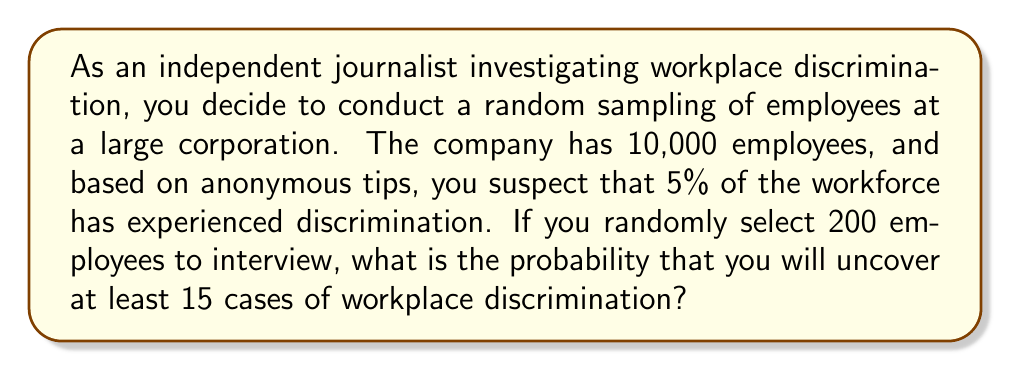Can you answer this question? To solve this problem, we need to use the binomial probability distribution, as we are dealing with a fixed number of independent trials (interviews) with two possible outcomes (experienced discrimination or not).

Let's define our variables:
$n = 200$ (number of employees interviewed)
$p = 0.05$ (probability of an employee experiencing discrimination)
$X$ = number of employees who have experienced discrimination

We want to find $P(X \geq 15)$

The probability mass function for a binomial distribution is:

$$P(X = k) = \binom{n}{k} p^k (1-p)^{n-k}$$

Where $\binom{n}{k}$ is the binomial coefficient.

To find $P(X \geq 15)$, we need to sum the probabilities of all outcomes from 15 to 200:

$$P(X \geq 15) = \sum_{k=15}^{200} \binom{200}{k} (0.05)^k (0.95)^{200-k}$$

This sum is computationally intensive, so we can use the complement rule:

$$P(X \geq 15) = 1 - P(X < 15) = 1 - P(X \leq 14)$$

Now we need to calculate:

$$1 - \sum_{k=0}^{14} \binom{200}{k} (0.05)^k (0.95)^{200-k}$$

Using a statistical calculator or software, we can compute this value.

The result of this calculation is approximately 0.8719.
Answer: The probability of uncovering at least 15 cases of workplace discrimination when randomly sampling 200 employees is approximately 0.8719 or 87.19%. 